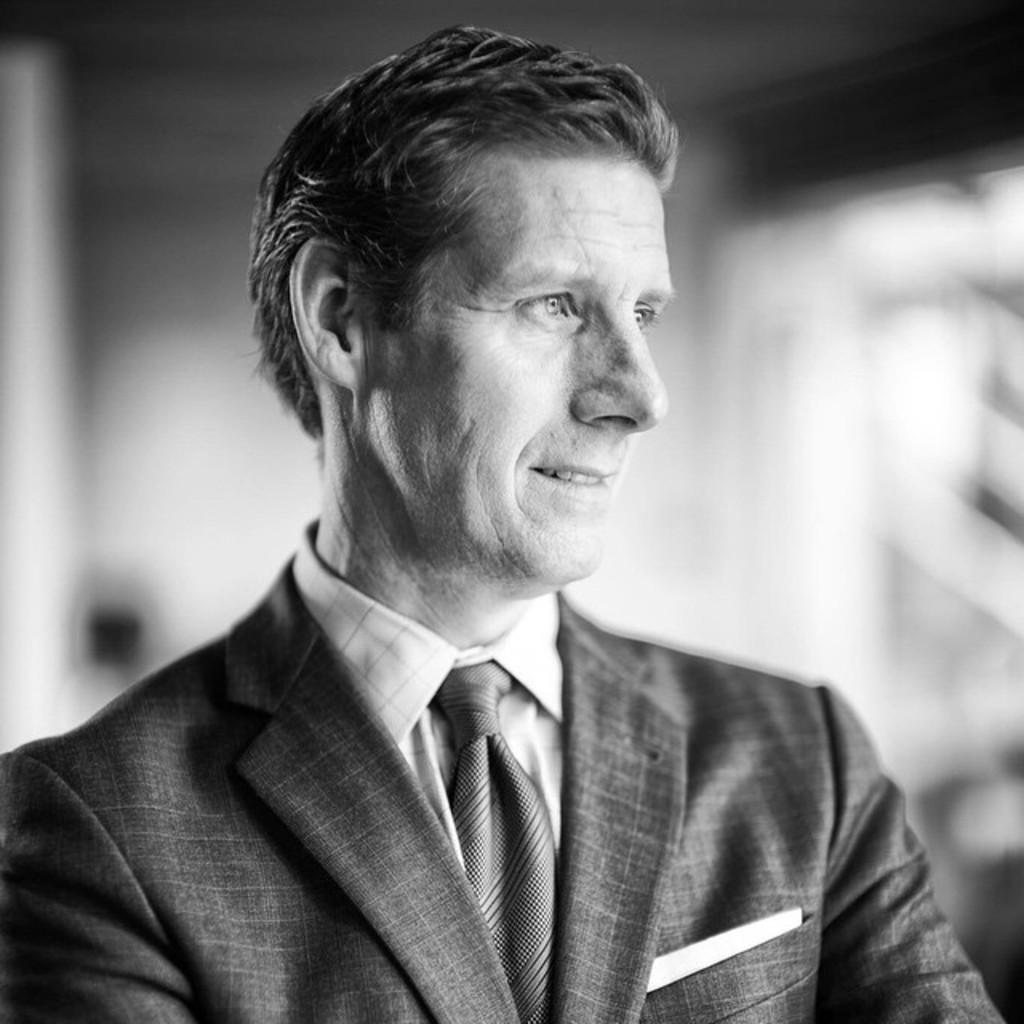What is the color scheme of the image? The image is black and white. Can you describe the person in the image? The person in the image is wearing a suit and a tie. What can be said about the background of the image? The background of the image is blurry. How much money does the person in the image have in their bank account? There is no information about the person's bank account in the image, so it cannot be determined. 